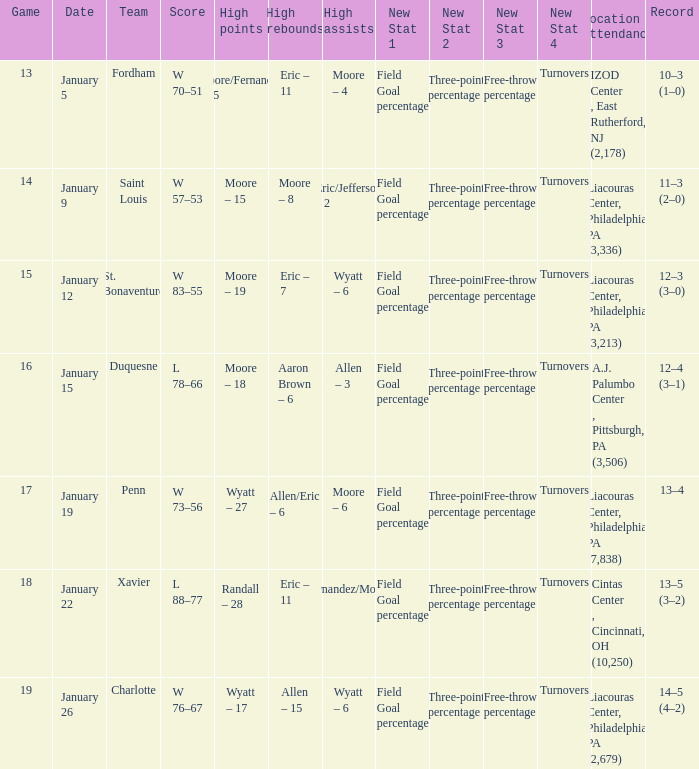What team was Temple playing on January 19? Penn. 